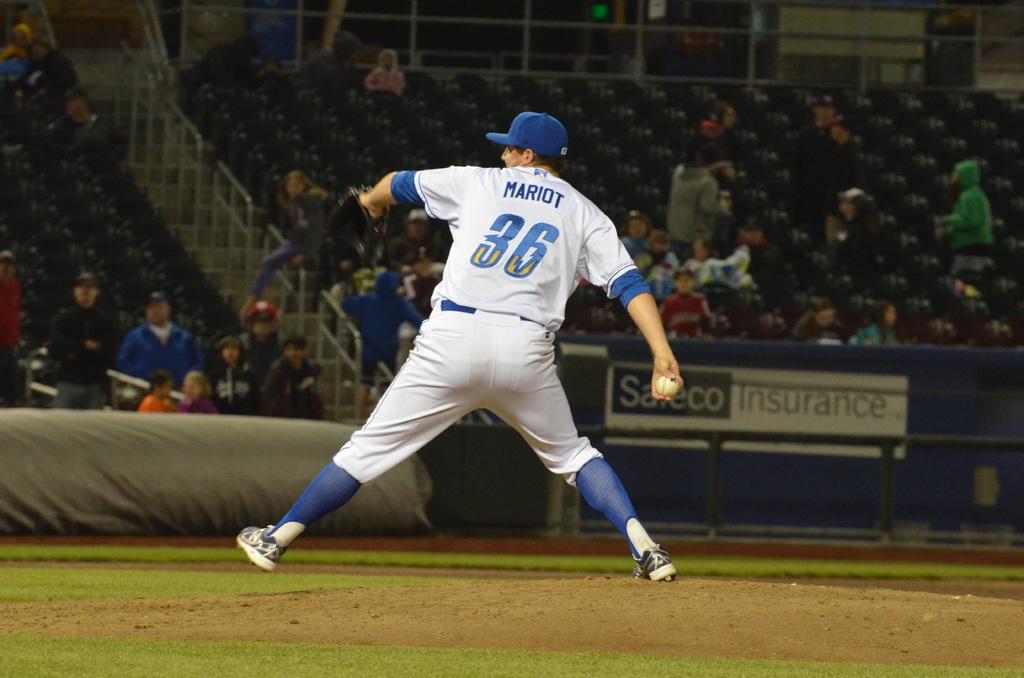What number is on his jersey?
Ensure brevity in your answer.  36. 